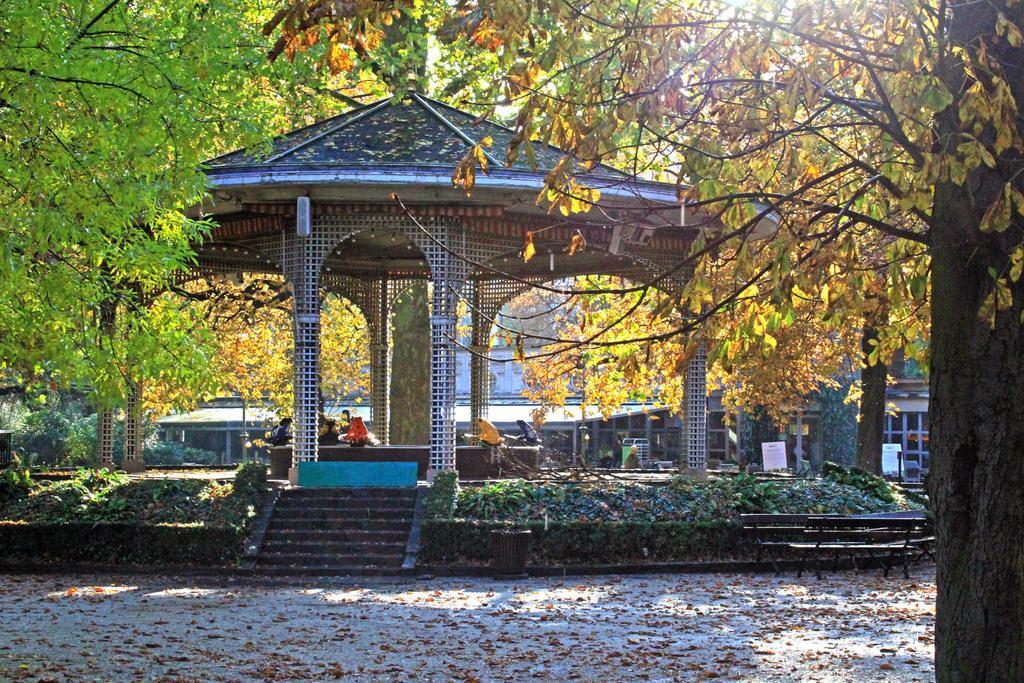In one or two sentences, can you explain what this image depicts? In the image there is a gazebo, around that there are few trees and behind the trees there is a building. 